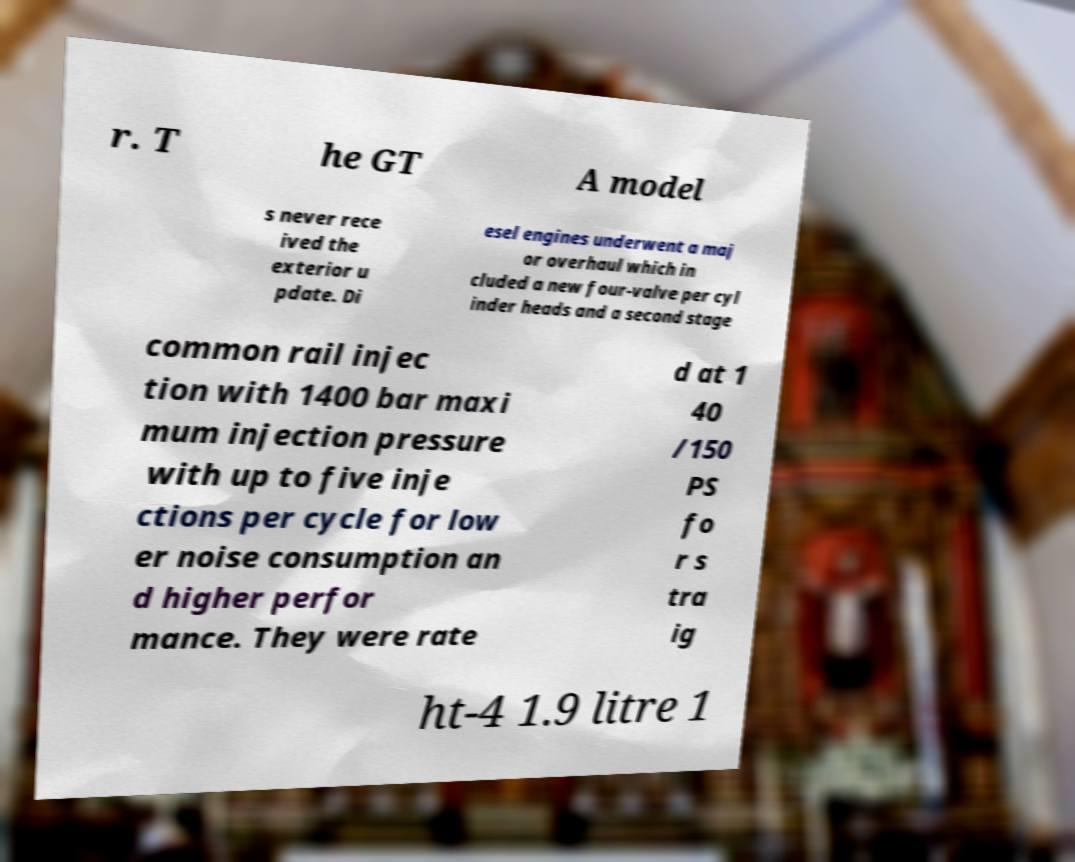Please identify and transcribe the text found in this image. r. T he GT A model s never rece ived the exterior u pdate. Di esel engines underwent a maj or overhaul which in cluded a new four-valve per cyl inder heads and a second stage common rail injec tion with 1400 bar maxi mum injection pressure with up to five inje ctions per cycle for low er noise consumption an d higher perfor mance. They were rate d at 1 40 /150 PS fo r s tra ig ht-4 1.9 litre 1 